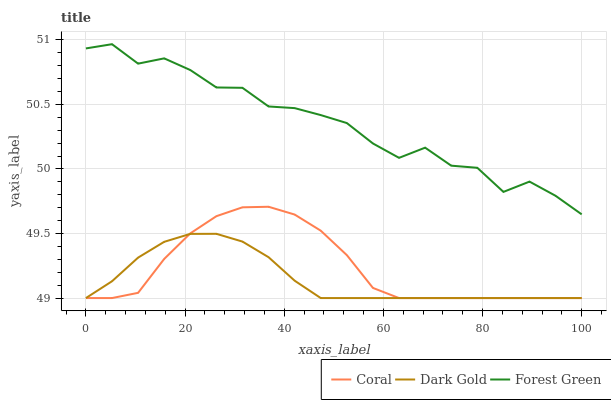Does Dark Gold have the minimum area under the curve?
Answer yes or no. Yes. Does Forest Green have the maximum area under the curve?
Answer yes or no. Yes. Does Forest Green have the minimum area under the curve?
Answer yes or no. No. Does Dark Gold have the maximum area under the curve?
Answer yes or no. No. Is Dark Gold the smoothest?
Answer yes or no. Yes. Is Forest Green the roughest?
Answer yes or no. Yes. Is Forest Green the smoothest?
Answer yes or no. No. Is Dark Gold the roughest?
Answer yes or no. No. Does Forest Green have the lowest value?
Answer yes or no. No. Does Forest Green have the highest value?
Answer yes or no. Yes. Does Dark Gold have the highest value?
Answer yes or no. No. Is Coral less than Forest Green?
Answer yes or no. Yes. Is Forest Green greater than Coral?
Answer yes or no. Yes. Does Coral intersect Dark Gold?
Answer yes or no. Yes. Is Coral less than Dark Gold?
Answer yes or no. No. Is Coral greater than Dark Gold?
Answer yes or no. No. Does Coral intersect Forest Green?
Answer yes or no. No. 